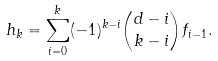Convert formula to latex. <formula><loc_0><loc_0><loc_500><loc_500>h _ { k } = \sum _ { i = 0 } ^ { k } ( - 1 ) ^ { k - i } \binom { d - i } { k - i } f _ { i - 1 } .</formula> 